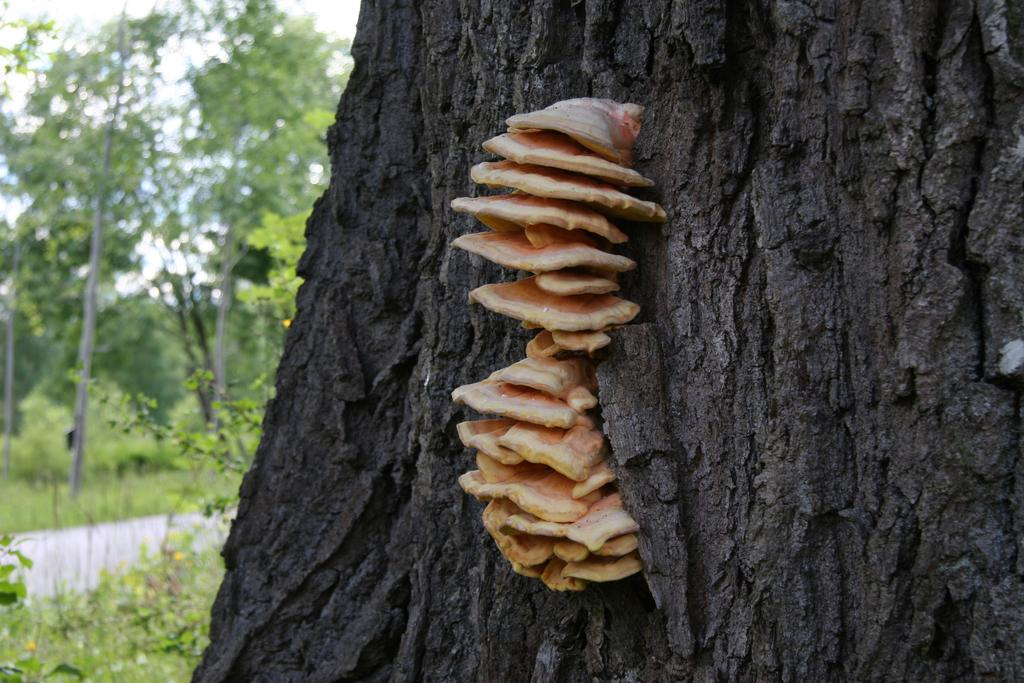What is growing on the tree trunk in the image? There is fungus on a tree trunk in the image. What can be seen in the background of the image? There are trees and plants in the background of the image. What is visible above the trees and plants in the image? The sky is visible in the background of the image. Where is the nearest airport to the location of the image? The provided facts do not give any information about the location of the image, so it is impossible to determine the nearest airport. 